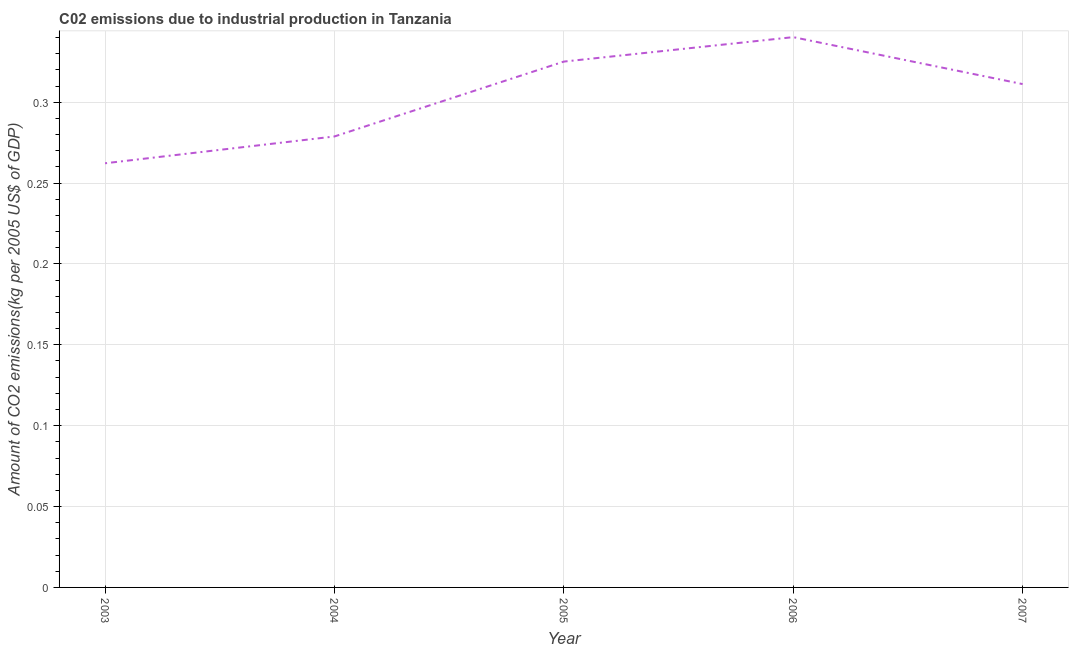What is the amount of co2 emissions in 2004?
Offer a terse response. 0.28. Across all years, what is the maximum amount of co2 emissions?
Offer a very short reply. 0.34. Across all years, what is the minimum amount of co2 emissions?
Keep it short and to the point. 0.26. In which year was the amount of co2 emissions minimum?
Your answer should be compact. 2003. What is the sum of the amount of co2 emissions?
Give a very brief answer. 1.52. What is the difference between the amount of co2 emissions in 2003 and 2007?
Provide a short and direct response. -0.05. What is the average amount of co2 emissions per year?
Ensure brevity in your answer.  0.3. What is the median amount of co2 emissions?
Provide a succinct answer. 0.31. In how many years, is the amount of co2 emissions greater than 0.30000000000000004 kg per 2005 US$ of GDP?
Keep it short and to the point. 3. What is the ratio of the amount of co2 emissions in 2003 to that in 2007?
Provide a succinct answer. 0.84. Is the amount of co2 emissions in 2006 less than that in 2007?
Your answer should be compact. No. Is the difference between the amount of co2 emissions in 2005 and 2006 greater than the difference between any two years?
Provide a succinct answer. No. What is the difference between the highest and the second highest amount of co2 emissions?
Offer a terse response. 0.02. Is the sum of the amount of co2 emissions in 2004 and 2005 greater than the maximum amount of co2 emissions across all years?
Offer a terse response. Yes. What is the difference between the highest and the lowest amount of co2 emissions?
Your response must be concise. 0.08. How many years are there in the graph?
Your answer should be compact. 5. What is the difference between two consecutive major ticks on the Y-axis?
Make the answer very short. 0.05. Are the values on the major ticks of Y-axis written in scientific E-notation?
Your response must be concise. No. Does the graph contain any zero values?
Ensure brevity in your answer.  No. What is the title of the graph?
Provide a succinct answer. C02 emissions due to industrial production in Tanzania. What is the label or title of the Y-axis?
Provide a short and direct response. Amount of CO2 emissions(kg per 2005 US$ of GDP). What is the Amount of CO2 emissions(kg per 2005 US$ of GDP) in 2003?
Provide a short and direct response. 0.26. What is the Amount of CO2 emissions(kg per 2005 US$ of GDP) of 2004?
Ensure brevity in your answer.  0.28. What is the Amount of CO2 emissions(kg per 2005 US$ of GDP) in 2005?
Your answer should be compact. 0.33. What is the Amount of CO2 emissions(kg per 2005 US$ of GDP) of 2006?
Your response must be concise. 0.34. What is the Amount of CO2 emissions(kg per 2005 US$ of GDP) of 2007?
Your answer should be very brief. 0.31. What is the difference between the Amount of CO2 emissions(kg per 2005 US$ of GDP) in 2003 and 2004?
Your answer should be very brief. -0.02. What is the difference between the Amount of CO2 emissions(kg per 2005 US$ of GDP) in 2003 and 2005?
Offer a very short reply. -0.06. What is the difference between the Amount of CO2 emissions(kg per 2005 US$ of GDP) in 2003 and 2006?
Ensure brevity in your answer.  -0.08. What is the difference between the Amount of CO2 emissions(kg per 2005 US$ of GDP) in 2003 and 2007?
Ensure brevity in your answer.  -0.05. What is the difference between the Amount of CO2 emissions(kg per 2005 US$ of GDP) in 2004 and 2005?
Provide a short and direct response. -0.05. What is the difference between the Amount of CO2 emissions(kg per 2005 US$ of GDP) in 2004 and 2006?
Give a very brief answer. -0.06. What is the difference between the Amount of CO2 emissions(kg per 2005 US$ of GDP) in 2004 and 2007?
Give a very brief answer. -0.03. What is the difference between the Amount of CO2 emissions(kg per 2005 US$ of GDP) in 2005 and 2006?
Your response must be concise. -0.02. What is the difference between the Amount of CO2 emissions(kg per 2005 US$ of GDP) in 2005 and 2007?
Keep it short and to the point. 0.01. What is the difference between the Amount of CO2 emissions(kg per 2005 US$ of GDP) in 2006 and 2007?
Ensure brevity in your answer.  0.03. What is the ratio of the Amount of CO2 emissions(kg per 2005 US$ of GDP) in 2003 to that in 2004?
Make the answer very short. 0.94. What is the ratio of the Amount of CO2 emissions(kg per 2005 US$ of GDP) in 2003 to that in 2005?
Offer a terse response. 0.81. What is the ratio of the Amount of CO2 emissions(kg per 2005 US$ of GDP) in 2003 to that in 2006?
Provide a short and direct response. 0.77. What is the ratio of the Amount of CO2 emissions(kg per 2005 US$ of GDP) in 2003 to that in 2007?
Provide a short and direct response. 0.84. What is the ratio of the Amount of CO2 emissions(kg per 2005 US$ of GDP) in 2004 to that in 2005?
Your response must be concise. 0.86. What is the ratio of the Amount of CO2 emissions(kg per 2005 US$ of GDP) in 2004 to that in 2006?
Give a very brief answer. 0.82. What is the ratio of the Amount of CO2 emissions(kg per 2005 US$ of GDP) in 2004 to that in 2007?
Your response must be concise. 0.9. What is the ratio of the Amount of CO2 emissions(kg per 2005 US$ of GDP) in 2005 to that in 2006?
Your answer should be very brief. 0.96. What is the ratio of the Amount of CO2 emissions(kg per 2005 US$ of GDP) in 2005 to that in 2007?
Your answer should be very brief. 1.04. What is the ratio of the Amount of CO2 emissions(kg per 2005 US$ of GDP) in 2006 to that in 2007?
Your answer should be very brief. 1.09. 